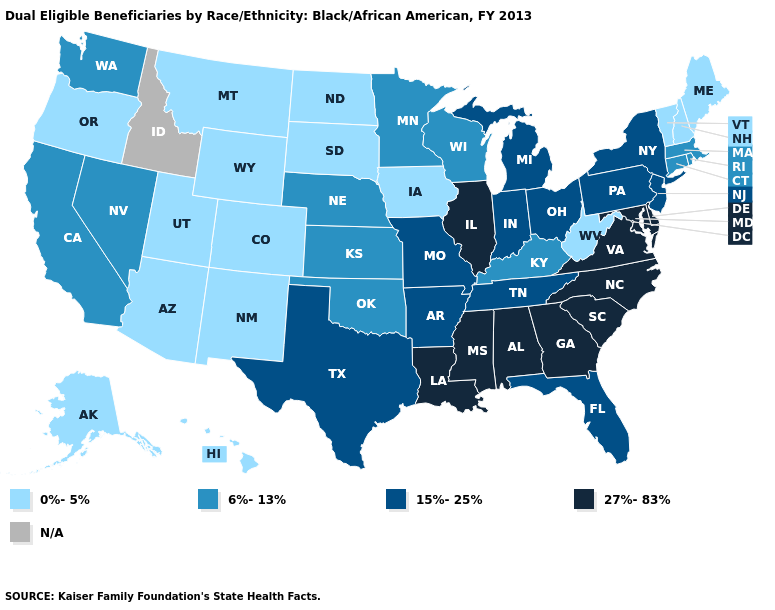Does Colorado have the highest value in the USA?
Give a very brief answer. No. Does Alabama have the highest value in the USA?
Be succinct. Yes. What is the value of Idaho?
Answer briefly. N/A. What is the lowest value in the MidWest?
Write a very short answer. 0%-5%. What is the value of North Dakota?
Concise answer only. 0%-5%. What is the value of Ohio?
Be succinct. 15%-25%. Name the states that have a value in the range 0%-5%?
Answer briefly. Alaska, Arizona, Colorado, Hawaii, Iowa, Maine, Montana, New Hampshire, New Mexico, North Dakota, Oregon, South Dakota, Utah, Vermont, West Virginia, Wyoming. What is the value of North Dakota?
Be succinct. 0%-5%. Name the states that have a value in the range 6%-13%?
Answer briefly. California, Connecticut, Kansas, Kentucky, Massachusetts, Minnesota, Nebraska, Nevada, Oklahoma, Rhode Island, Washington, Wisconsin. Name the states that have a value in the range 6%-13%?
Keep it brief. California, Connecticut, Kansas, Kentucky, Massachusetts, Minnesota, Nebraska, Nevada, Oklahoma, Rhode Island, Washington, Wisconsin. Does Wyoming have the lowest value in the USA?
Answer briefly. Yes. 